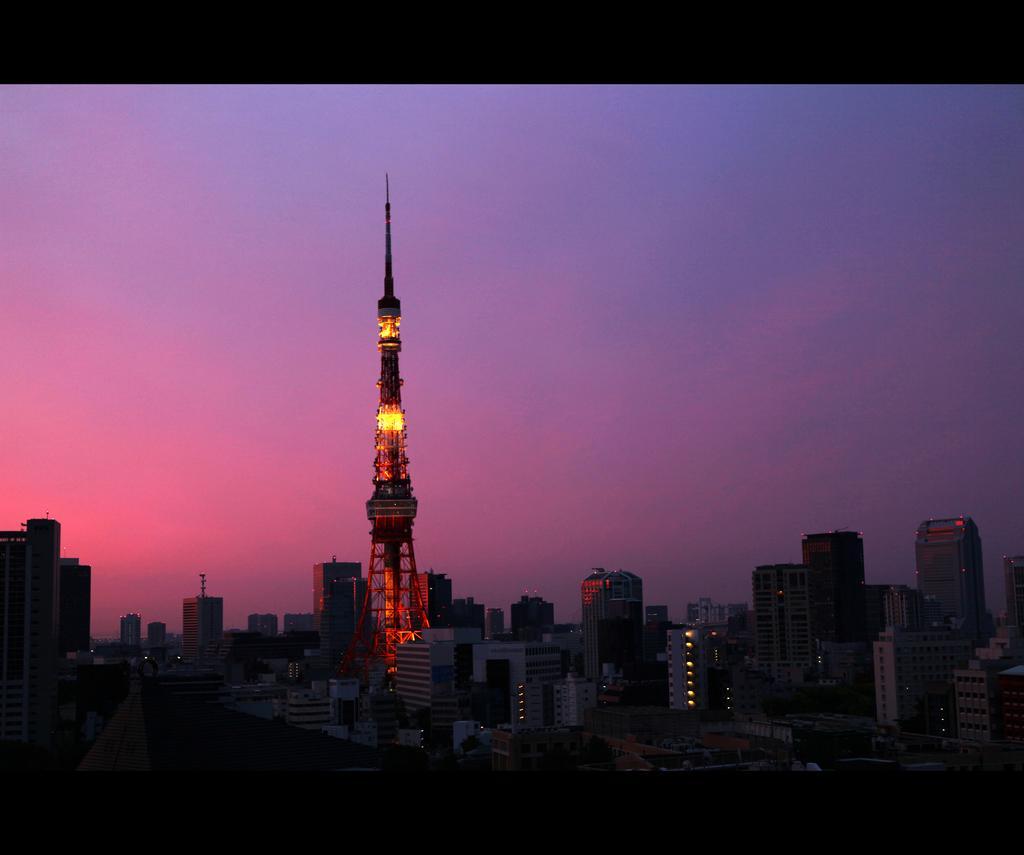In one or two sentences, can you explain what this image depicts? In this picture we can see many buildings, skyscrapers and tower. On the top we can see sky and clouds. On the bottom we can see trees and road. 